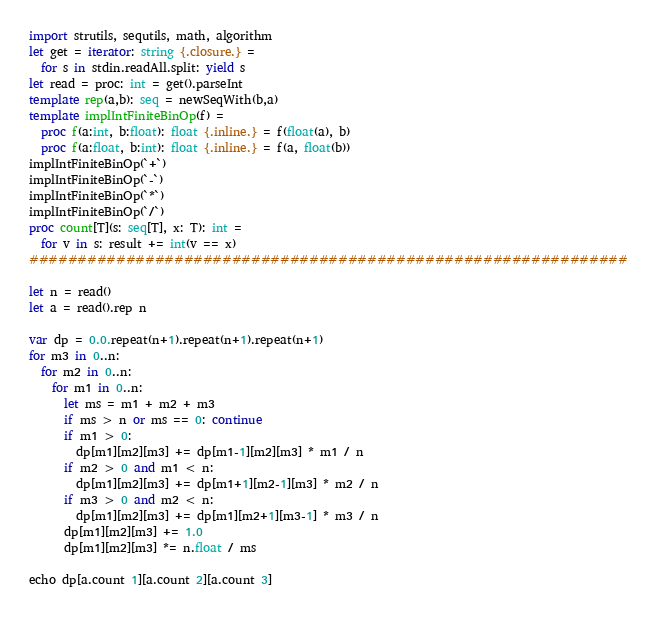Convert code to text. <code><loc_0><loc_0><loc_500><loc_500><_Nim_>import strutils, sequtils, math, algorithm
let get = iterator: string {.closure.} =
  for s in stdin.readAll.split: yield s
let read = proc: int = get().parseInt
template rep(a,b): seq = newSeqWith(b,a)
template implIntFiniteBinOp(f) =
  proc f(a:int, b:float): float {.inline.} = f(float(a), b)
  proc f(a:float, b:int): float {.inline.} = f(a, float(b))
implIntFiniteBinOp(`+`)
implIntFiniteBinOp(`-`)
implIntFiniteBinOp(`*`)
implIntFiniteBinOp(`/`)
proc count[T](s: seq[T], x: T): int =
  for v in s: result += int(v == x)
##############################################################

let n = read()
let a = read().rep n

var dp = 0.0.repeat(n+1).repeat(n+1).repeat(n+1)
for m3 in 0..n:
  for m2 in 0..n:
    for m1 in 0..n:
      let ms = m1 + m2 + m3
      if ms > n or ms == 0: continue
      if m1 > 0:
        dp[m1][m2][m3] += dp[m1-1][m2][m3] * m1 / n
      if m2 > 0 and m1 < n:
        dp[m1][m2][m3] += dp[m1+1][m2-1][m3] * m2 / n
      if m3 > 0 and m2 < n:
        dp[m1][m2][m3] += dp[m1][m2+1][m3-1] * m3 / n
      dp[m1][m2][m3] += 1.0
      dp[m1][m2][m3] *= n.float / ms

echo dp[a.count 1][a.count 2][a.count 3]
</code> 